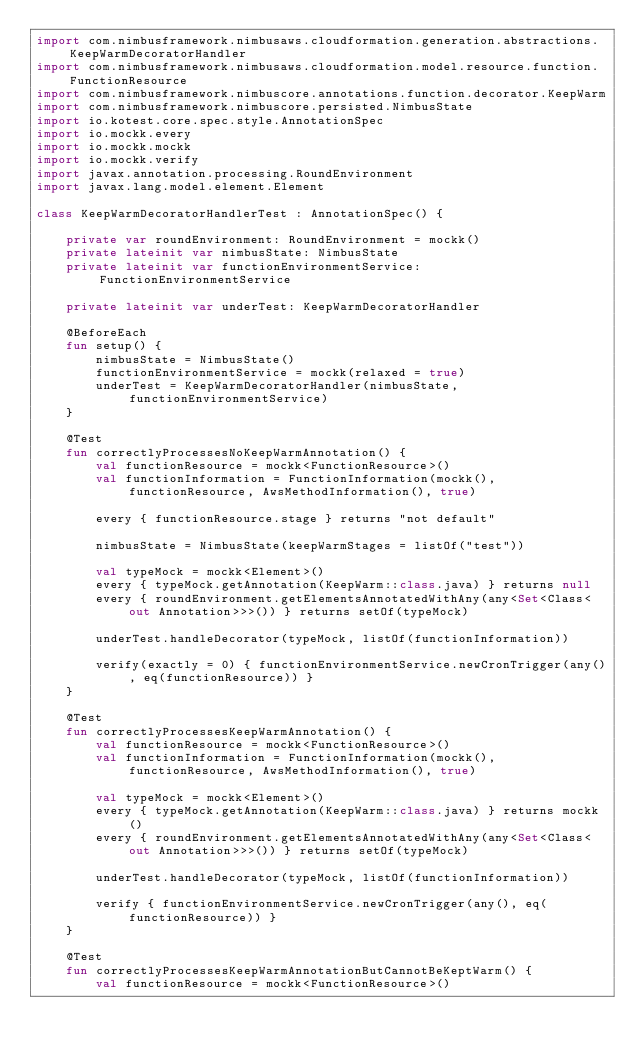Convert code to text. <code><loc_0><loc_0><loc_500><loc_500><_Kotlin_>import com.nimbusframework.nimbusaws.cloudformation.generation.abstractions.KeepWarmDecoratorHandler
import com.nimbusframework.nimbusaws.cloudformation.model.resource.function.FunctionResource
import com.nimbusframework.nimbuscore.annotations.function.decorator.KeepWarm
import com.nimbusframework.nimbuscore.persisted.NimbusState
import io.kotest.core.spec.style.AnnotationSpec
import io.mockk.every
import io.mockk.mockk
import io.mockk.verify
import javax.annotation.processing.RoundEnvironment
import javax.lang.model.element.Element

class KeepWarmDecoratorHandlerTest : AnnotationSpec() {

    private var roundEnvironment: RoundEnvironment = mockk()
    private lateinit var nimbusState: NimbusState
    private lateinit var functionEnvironmentService: FunctionEnvironmentService

    private lateinit var underTest: KeepWarmDecoratorHandler

    @BeforeEach
    fun setup() {
        nimbusState = NimbusState()
        functionEnvironmentService = mockk(relaxed = true)
        underTest = KeepWarmDecoratorHandler(nimbusState, functionEnvironmentService)
    }

    @Test
    fun correctlyProcessesNoKeepWarmAnnotation() {
        val functionResource = mockk<FunctionResource>()
        val functionInformation = FunctionInformation(mockk(), functionResource, AwsMethodInformation(), true)

        every { functionResource.stage } returns "not default"

        nimbusState = NimbusState(keepWarmStages = listOf("test"))

        val typeMock = mockk<Element>()
        every { typeMock.getAnnotation(KeepWarm::class.java) } returns null
        every { roundEnvironment.getElementsAnnotatedWithAny(any<Set<Class<out Annotation>>>()) } returns setOf(typeMock)

        underTest.handleDecorator(typeMock, listOf(functionInformation))

        verify(exactly = 0) { functionEnvironmentService.newCronTrigger(any(), eq(functionResource)) }
    }

    @Test
    fun correctlyProcessesKeepWarmAnnotation() {
        val functionResource = mockk<FunctionResource>()
        val functionInformation = FunctionInformation(mockk(), functionResource, AwsMethodInformation(), true)

        val typeMock = mockk<Element>()
        every { typeMock.getAnnotation(KeepWarm::class.java) } returns mockk()
        every { roundEnvironment.getElementsAnnotatedWithAny(any<Set<Class<out Annotation>>>()) } returns setOf(typeMock)

        underTest.handleDecorator(typeMock, listOf(functionInformation))

        verify { functionEnvironmentService.newCronTrigger(any(), eq(functionResource)) }
    }

    @Test
    fun correctlyProcessesKeepWarmAnnotationButCannotBeKeptWarm() {
        val functionResource = mockk<FunctionResource>()</code> 